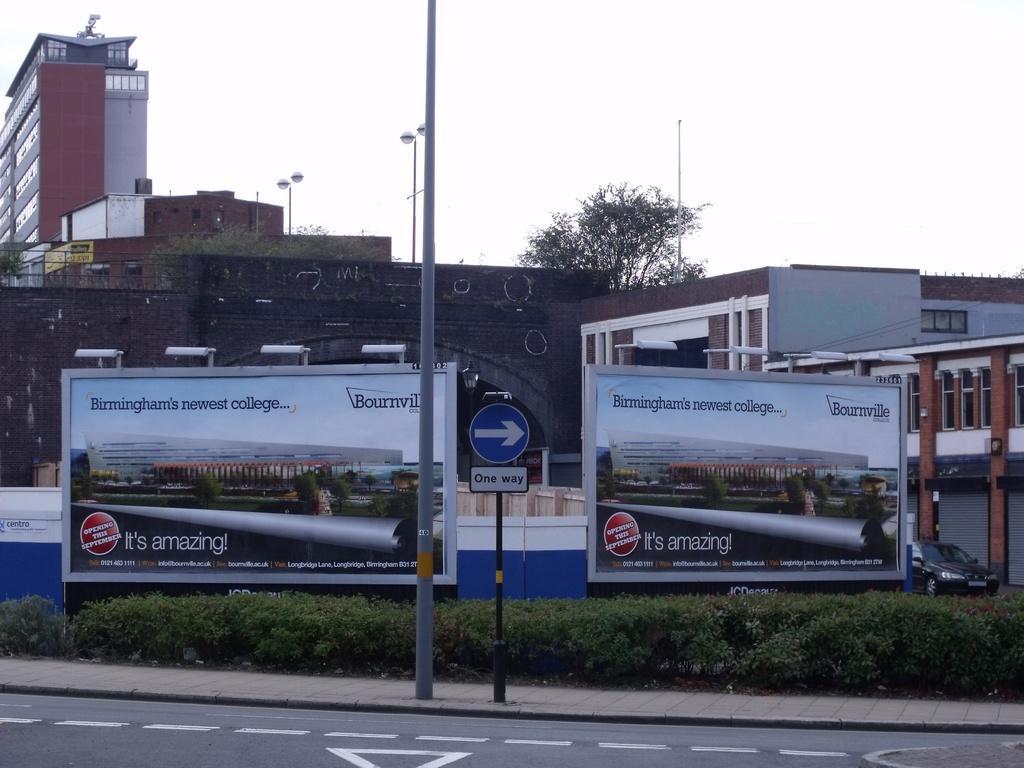In one or two sentences, can you explain what this image depicts? At the bottom of the image there is a road and a hedge. In the center there are hoardings and we can see a sign board. In the background there are buildings, poles, trees and sky. On the right there is a car. 